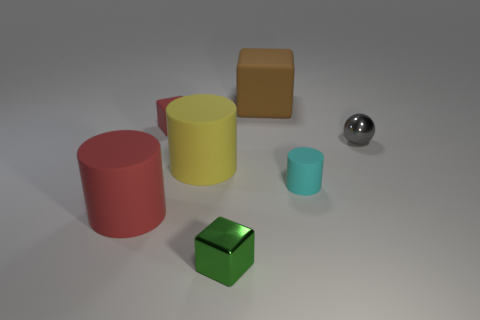There is a big yellow object that is the same material as the red cylinder; what is its shape? The big yellow object has a cylindrical shape, akin to the red cylinder but taller in height, giving it a more elongated appearance. 